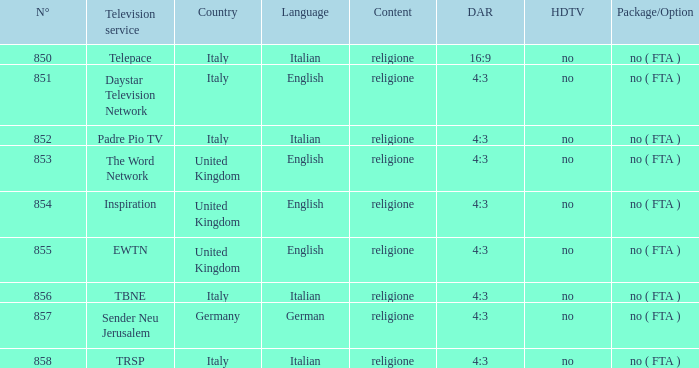What television service are in the united kingdom and n° is greater than 854.0? EWTN. 